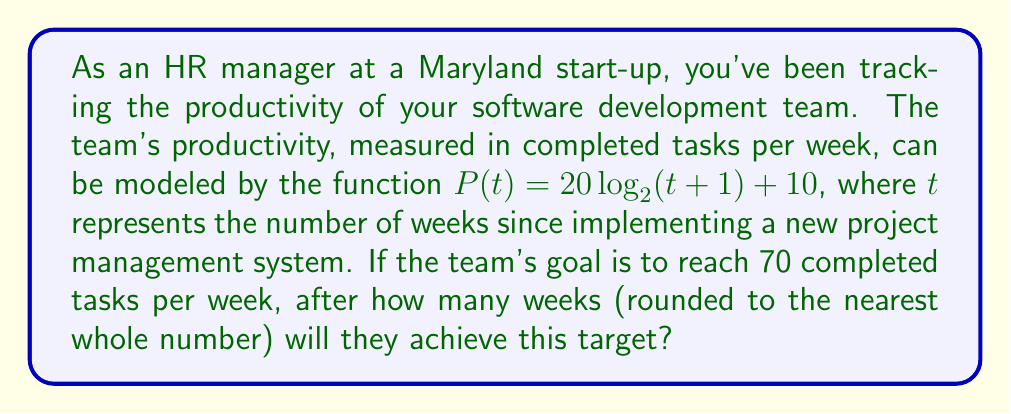Can you solve this math problem? Let's approach this step-by-step:

1) We need to solve the equation:
   $P(t) = 70$

2) Substituting the given function:
   $20 \log_2(t+1) + 10 = 70$

3) Subtract 10 from both sides:
   $20 \log_2(t+1) = 60$

4) Divide both sides by 20:
   $\log_2(t+1) = 3$

5) Now, we need to solve for $t$. We can do this by applying $2^x$ to both sides:
   $2^{\log_2(t+1)} = 2^3$

6) The left side simplifies to $(t+1)$:
   $t + 1 = 2^3 = 8$

7) Subtract 1 from both sides:
   $t = 7$

8) Since we're asked to round to the nearest whole number, and 7 is already a whole number, our answer is 7 weeks.
Answer: 7 weeks 